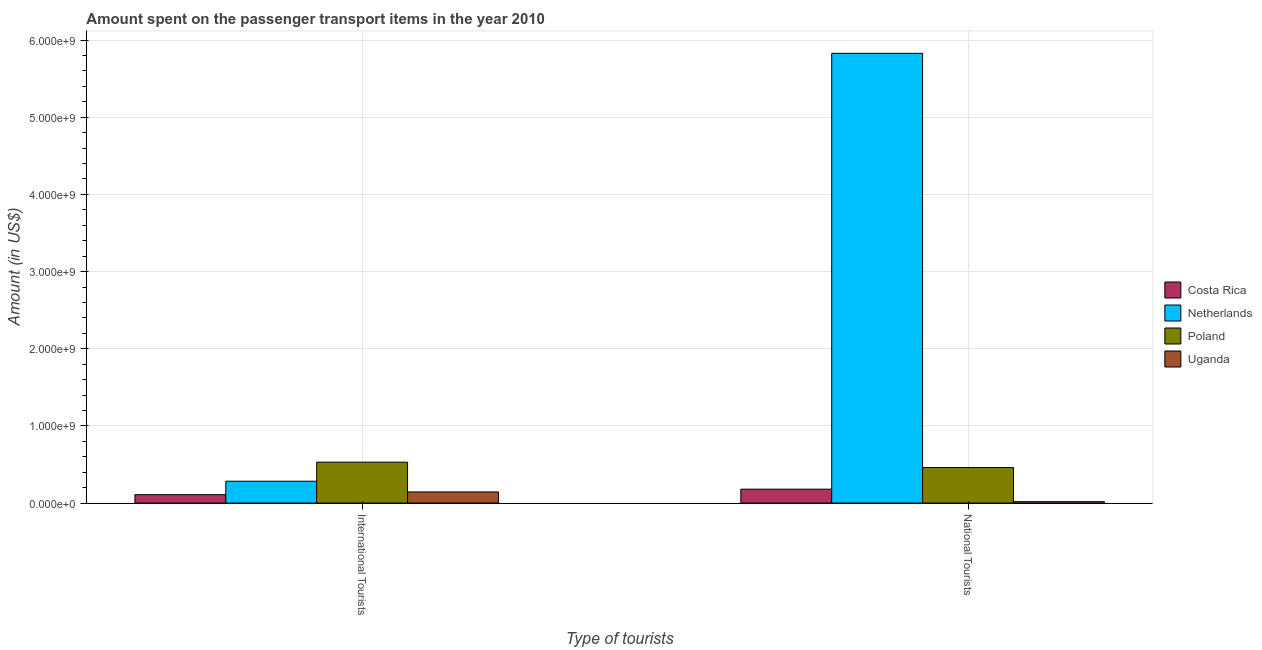How many different coloured bars are there?
Offer a very short reply. 4. Are the number of bars per tick equal to the number of legend labels?
Ensure brevity in your answer.  Yes. Are the number of bars on each tick of the X-axis equal?
Offer a terse response. Yes. How many bars are there on the 1st tick from the left?
Your answer should be compact. 4. What is the label of the 2nd group of bars from the left?
Give a very brief answer. National Tourists. What is the amount spent on transport items of international tourists in Netherlands?
Give a very brief answer. 2.83e+08. Across all countries, what is the maximum amount spent on transport items of international tourists?
Offer a terse response. 5.30e+08. Across all countries, what is the minimum amount spent on transport items of national tourists?
Your answer should be very brief. 1.80e+07. In which country was the amount spent on transport items of international tourists maximum?
Keep it short and to the point. Poland. What is the total amount spent on transport items of national tourists in the graph?
Keep it short and to the point. 6.49e+09. What is the difference between the amount spent on transport items of national tourists in Poland and that in Costa Rica?
Give a very brief answer. 2.80e+08. What is the difference between the amount spent on transport items of international tourists in Costa Rica and the amount spent on transport items of national tourists in Netherlands?
Your answer should be very brief. -5.72e+09. What is the average amount spent on transport items of national tourists per country?
Provide a succinct answer. 1.62e+09. What is the difference between the amount spent on transport items of national tourists and amount spent on transport items of international tourists in Poland?
Offer a terse response. -7.00e+07. What is the ratio of the amount spent on transport items of international tourists in Poland to that in Netherlands?
Offer a terse response. 1.87. In how many countries, is the amount spent on transport items of international tourists greater than the average amount spent on transport items of international tourists taken over all countries?
Keep it short and to the point. 2. What does the 1st bar from the left in National Tourists represents?
Offer a terse response. Costa Rica. What does the 1st bar from the right in International Tourists represents?
Keep it short and to the point. Uganda. Are all the bars in the graph horizontal?
Your answer should be very brief. No. Does the graph contain any zero values?
Your response must be concise. No. Where does the legend appear in the graph?
Make the answer very short. Center right. How many legend labels are there?
Your response must be concise. 4. How are the legend labels stacked?
Keep it short and to the point. Vertical. What is the title of the graph?
Offer a very short reply. Amount spent on the passenger transport items in the year 2010. Does "East Asia (developing only)" appear as one of the legend labels in the graph?
Offer a very short reply. No. What is the label or title of the X-axis?
Provide a succinct answer. Type of tourists. What is the label or title of the Y-axis?
Your answer should be compact. Amount (in US$). What is the Amount (in US$) in Costa Rica in International Tourists?
Your answer should be very brief. 1.09e+08. What is the Amount (in US$) of Netherlands in International Tourists?
Give a very brief answer. 2.83e+08. What is the Amount (in US$) of Poland in International Tourists?
Give a very brief answer. 5.30e+08. What is the Amount (in US$) in Uganda in International Tourists?
Your answer should be very brief. 1.44e+08. What is the Amount (in US$) of Costa Rica in National Tourists?
Your response must be concise. 1.80e+08. What is the Amount (in US$) of Netherlands in National Tourists?
Keep it short and to the point. 5.83e+09. What is the Amount (in US$) of Poland in National Tourists?
Offer a very short reply. 4.60e+08. What is the Amount (in US$) of Uganda in National Tourists?
Ensure brevity in your answer.  1.80e+07. Across all Type of tourists, what is the maximum Amount (in US$) of Costa Rica?
Your response must be concise. 1.80e+08. Across all Type of tourists, what is the maximum Amount (in US$) of Netherlands?
Your answer should be compact. 5.83e+09. Across all Type of tourists, what is the maximum Amount (in US$) in Poland?
Give a very brief answer. 5.30e+08. Across all Type of tourists, what is the maximum Amount (in US$) of Uganda?
Ensure brevity in your answer.  1.44e+08. Across all Type of tourists, what is the minimum Amount (in US$) in Costa Rica?
Give a very brief answer. 1.09e+08. Across all Type of tourists, what is the minimum Amount (in US$) in Netherlands?
Ensure brevity in your answer.  2.83e+08. Across all Type of tourists, what is the minimum Amount (in US$) of Poland?
Make the answer very short. 4.60e+08. Across all Type of tourists, what is the minimum Amount (in US$) in Uganda?
Give a very brief answer. 1.80e+07. What is the total Amount (in US$) in Costa Rica in the graph?
Ensure brevity in your answer.  2.89e+08. What is the total Amount (in US$) in Netherlands in the graph?
Your response must be concise. 6.11e+09. What is the total Amount (in US$) in Poland in the graph?
Your response must be concise. 9.90e+08. What is the total Amount (in US$) of Uganda in the graph?
Offer a very short reply. 1.62e+08. What is the difference between the Amount (in US$) in Costa Rica in International Tourists and that in National Tourists?
Ensure brevity in your answer.  -7.10e+07. What is the difference between the Amount (in US$) of Netherlands in International Tourists and that in National Tourists?
Give a very brief answer. -5.55e+09. What is the difference between the Amount (in US$) of Poland in International Tourists and that in National Tourists?
Your answer should be very brief. 7.00e+07. What is the difference between the Amount (in US$) of Uganda in International Tourists and that in National Tourists?
Your response must be concise. 1.26e+08. What is the difference between the Amount (in US$) in Costa Rica in International Tourists and the Amount (in US$) in Netherlands in National Tourists?
Offer a very short reply. -5.72e+09. What is the difference between the Amount (in US$) in Costa Rica in International Tourists and the Amount (in US$) in Poland in National Tourists?
Your answer should be compact. -3.51e+08. What is the difference between the Amount (in US$) in Costa Rica in International Tourists and the Amount (in US$) in Uganda in National Tourists?
Provide a succinct answer. 9.10e+07. What is the difference between the Amount (in US$) in Netherlands in International Tourists and the Amount (in US$) in Poland in National Tourists?
Ensure brevity in your answer.  -1.77e+08. What is the difference between the Amount (in US$) in Netherlands in International Tourists and the Amount (in US$) in Uganda in National Tourists?
Provide a short and direct response. 2.65e+08. What is the difference between the Amount (in US$) in Poland in International Tourists and the Amount (in US$) in Uganda in National Tourists?
Keep it short and to the point. 5.12e+08. What is the average Amount (in US$) in Costa Rica per Type of tourists?
Provide a short and direct response. 1.44e+08. What is the average Amount (in US$) of Netherlands per Type of tourists?
Keep it short and to the point. 3.06e+09. What is the average Amount (in US$) in Poland per Type of tourists?
Make the answer very short. 4.95e+08. What is the average Amount (in US$) of Uganda per Type of tourists?
Keep it short and to the point. 8.10e+07. What is the difference between the Amount (in US$) of Costa Rica and Amount (in US$) of Netherlands in International Tourists?
Make the answer very short. -1.74e+08. What is the difference between the Amount (in US$) of Costa Rica and Amount (in US$) of Poland in International Tourists?
Provide a short and direct response. -4.21e+08. What is the difference between the Amount (in US$) in Costa Rica and Amount (in US$) in Uganda in International Tourists?
Offer a very short reply. -3.50e+07. What is the difference between the Amount (in US$) of Netherlands and Amount (in US$) of Poland in International Tourists?
Your answer should be very brief. -2.47e+08. What is the difference between the Amount (in US$) of Netherlands and Amount (in US$) of Uganda in International Tourists?
Your response must be concise. 1.39e+08. What is the difference between the Amount (in US$) in Poland and Amount (in US$) in Uganda in International Tourists?
Offer a very short reply. 3.86e+08. What is the difference between the Amount (in US$) of Costa Rica and Amount (in US$) of Netherlands in National Tourists?
Provide a short and direct response. -5.65e+09. What is the difference between the Amount (in US$) in Costa Rica and Amount (in US$) in Poland in National Tourists?
Your answer should be very brief. -2.80e+08. What is the difference between the Amount (in US$) of Costa Rica and Amount (in US$) of Uganda in National Tourists?
Offer a very short reply. 1.62e+08. What is the difference between the Amount (in US$) of Netherlands and Amount (in US$) of Poland in National Tourists?
Ensure brevity in your answer.  5.37e+09. What is the difference between the Amount (in US$) in Netherlands and Amount (in US$) in Uganda in National Tourists?
Provide a short and direct response. 5.81e+09. What is the difference between the Amount (in US$) of Poland and Amount (in US$) of Uganda in National Tourists?
Ensure brevity in your answer.  4.42e+08. What is the ratio of the Amount (in US$) in Costa Rica in International Tourists to that in National Tourists?
Offer a very short reply. 0.61. What is the ratio of the Amount (in US$) of Netherlands in International Tourists to that in National Tourists?
Offer a very short reply. 0.05. What is the ratio of the Amount (in US$) in Poland in International Tourists to that in National Tourists?
Offer a very short reply. 1.15. What is the difference between the highest and the second highest Amount (in US$) of Costa Rica?
Keep it short and to the point. 7.10e+07. What is the difference between the highest and the second highest Amount (in US$) of Netherlands?
Give a very brief answer. 5.55e+09. What is the difference between the highest and the second highest Amount (in US$) in Poland?
Keep it short and to the point. 7.00e+07. What is the difference between the highest and the second highest Amount (in US$) in Uganda?
Your answer should be compact. 1.26e+08. What is the difference between the highest and the lowest Amount (in US$) in Costa Rica?
Provide a succinct answer. 7.10e+07. What is the difference between the highest and the lowest Amount (in US$) in Netherlands?
Provide a short and direct response. 5.55e+09. What is the difference between the highest and the lowest Amount (in US$) of Poland?
Your answer should be very brief. 7.00e+07. What is the difference between the highest and the lowest Amount (in US$) of Uganda?
Provide a short and direct response. 1.26e+08. 